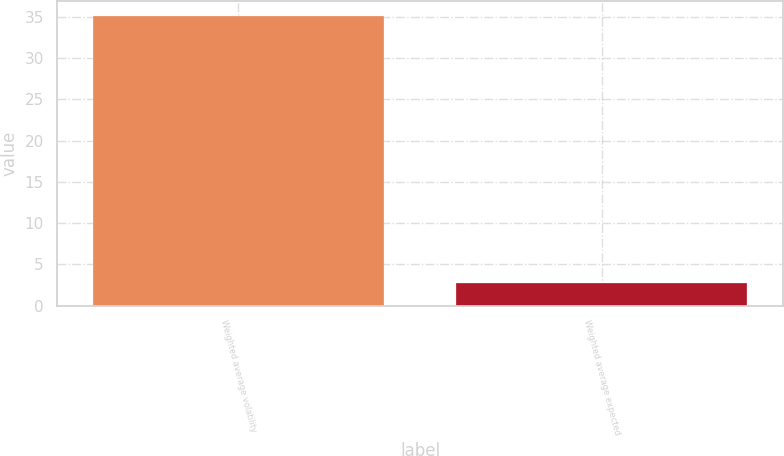<chart> <loc_0><loc_0><loc_500><loc_500><bar_chart><fcel>Weighted average volatility<fcel>Weighted average expected<nl><fcel>35.1<fcel>2.7<nl></chart> 